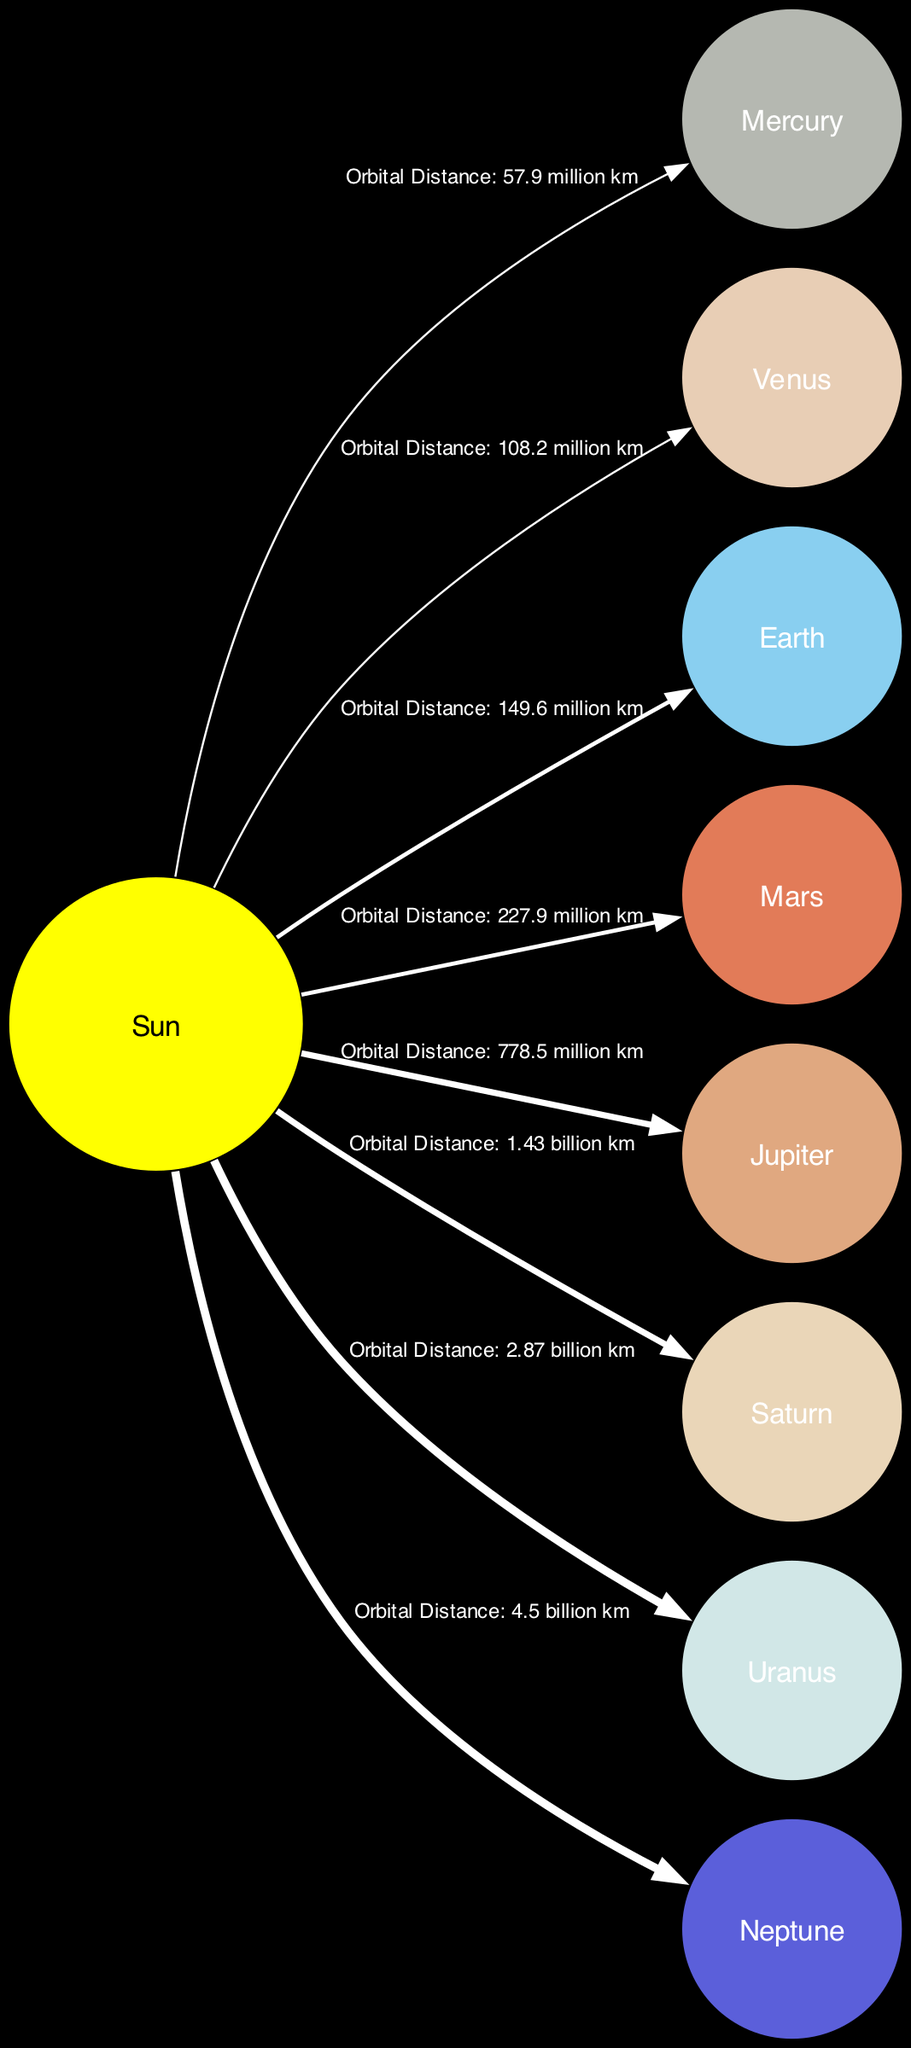What is the orbital distance of Mars from the Sun? Referring to the edge labeled from the Sun to Mars, the diagram specifies the orbital distance as 227.9 million km.
Answer: 227.9 million km Which planet is closest to the Sun? The diagram identifies Mercury as the planet closest to the Sun, as it has the shortest orbital distance of 57.9 million km indicated from the Sun.
Answer: Mercury How many planets are shown in the diagram? By counting the nodes representing each celestial body in the diagram (Sun and 8 planets), we find a total of 9 nodes.
Answer: 9 Which planet has the highest orbital distance from the Sun? The edge connecting the Sun to Neptune shows the greatest orbital distance labeled as 4.5 billion km, making Neptune the furthest planet from the Sun.
Answer: Neptune What color represents Jupiter in the diagram? The node for Jupiter is colored a light brown, specifically indicated by the hex color #E0A880 assigned in the color mapping of the diagram.
Answer: Light brown Which two planets have animated trajectories? The edges labeled from the Sun to Jupiter, and from the Sun to Saturn are indicated to be animated, highlighting their higher energetic dynamics compared to others.
Answer: Jupiter and Saturn What is the unique feature of Uranus as depicted in this diagram? The diagram notes that Uranus has a unique tilt that causes extreme seasons, distinguished prominently in its description node.
Answer: Unique tilt What is the color scheme used for Venus in this diagram? The diagram describes Venus with a fill color of a soft peach tone, specifically indicated by the hex color #E8CEB5 in the node attributes.
Answer: Soft peach tone How is the gravitational influence of the Sun depicted in the diagram? The Sun is depicted at the center of the diagram as providing the gravitational pull that all planets orbit around, as evidenced by the directional edges pointing from it to each planet.
Answer: Provides gravitational pull 